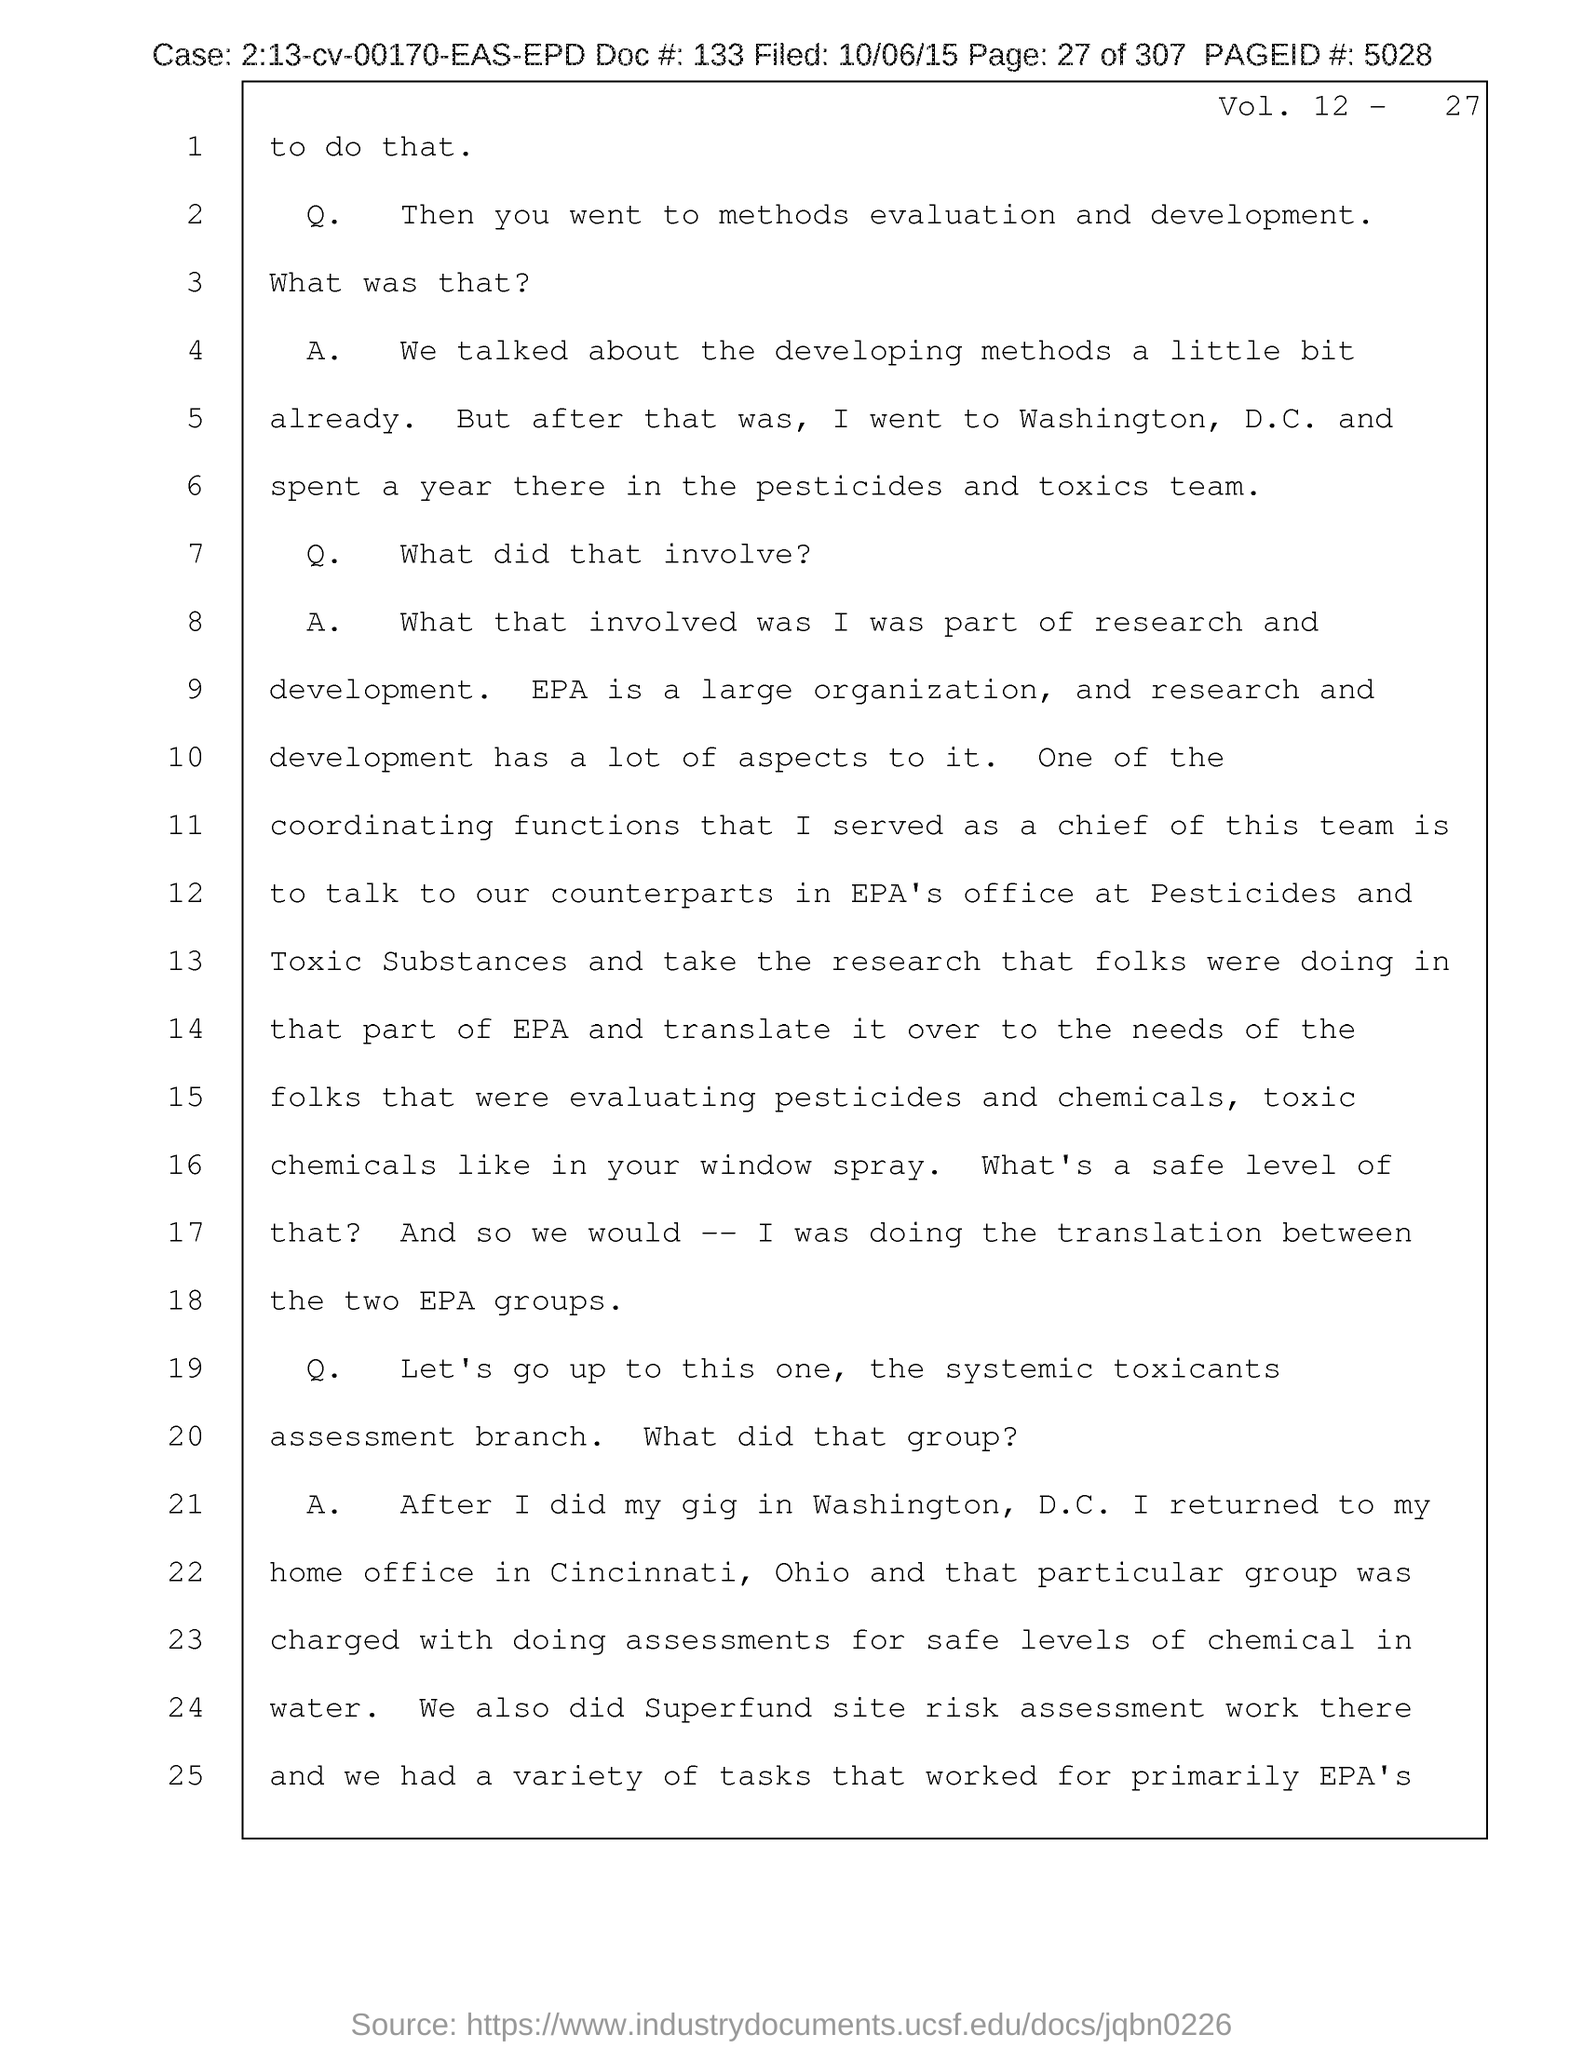What is the page no mentioned in this document?
Offer a terse response. 27 of 307. What is the Page ID # given in the document?
Your response must be concise. 5028. What is the case no mentioned in the document?
Offer a very short reply. 2:13-cv-00170-EAS-EPD. What is the doc # given in the document?
Your answer should be very brief. 133. What is the filed date of the document?
Offer a very short reply. 10/06/15. What is the Vol. no. given in the document?
Your response must be concise. 12. 